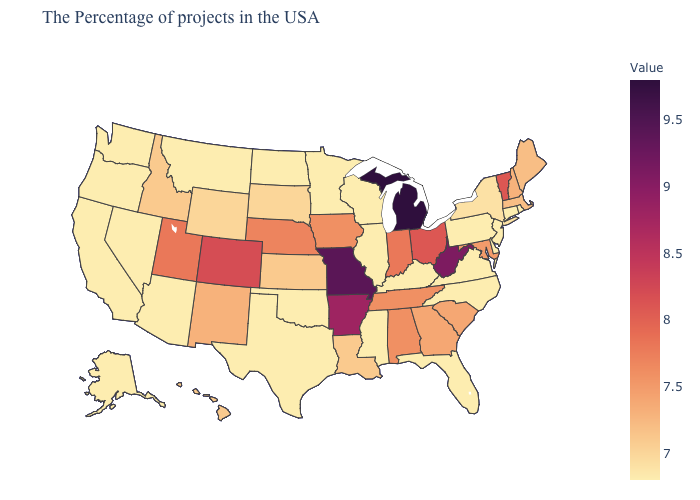Among the states that border Indiana , does Illinois have the lowest value?
Answer briefly. Yes. Among the states that border Rhode Island , which have the highest value?
Keep it brief. Massachusetts. Among the states that border South Dakota , does Wyoming have the lowest value?
Answer briefly. No. Does New Mexico have the lowest value in the West?
Keep it brief. No. Does Maine have the highest value in the USA?
Answer briefly. No. 